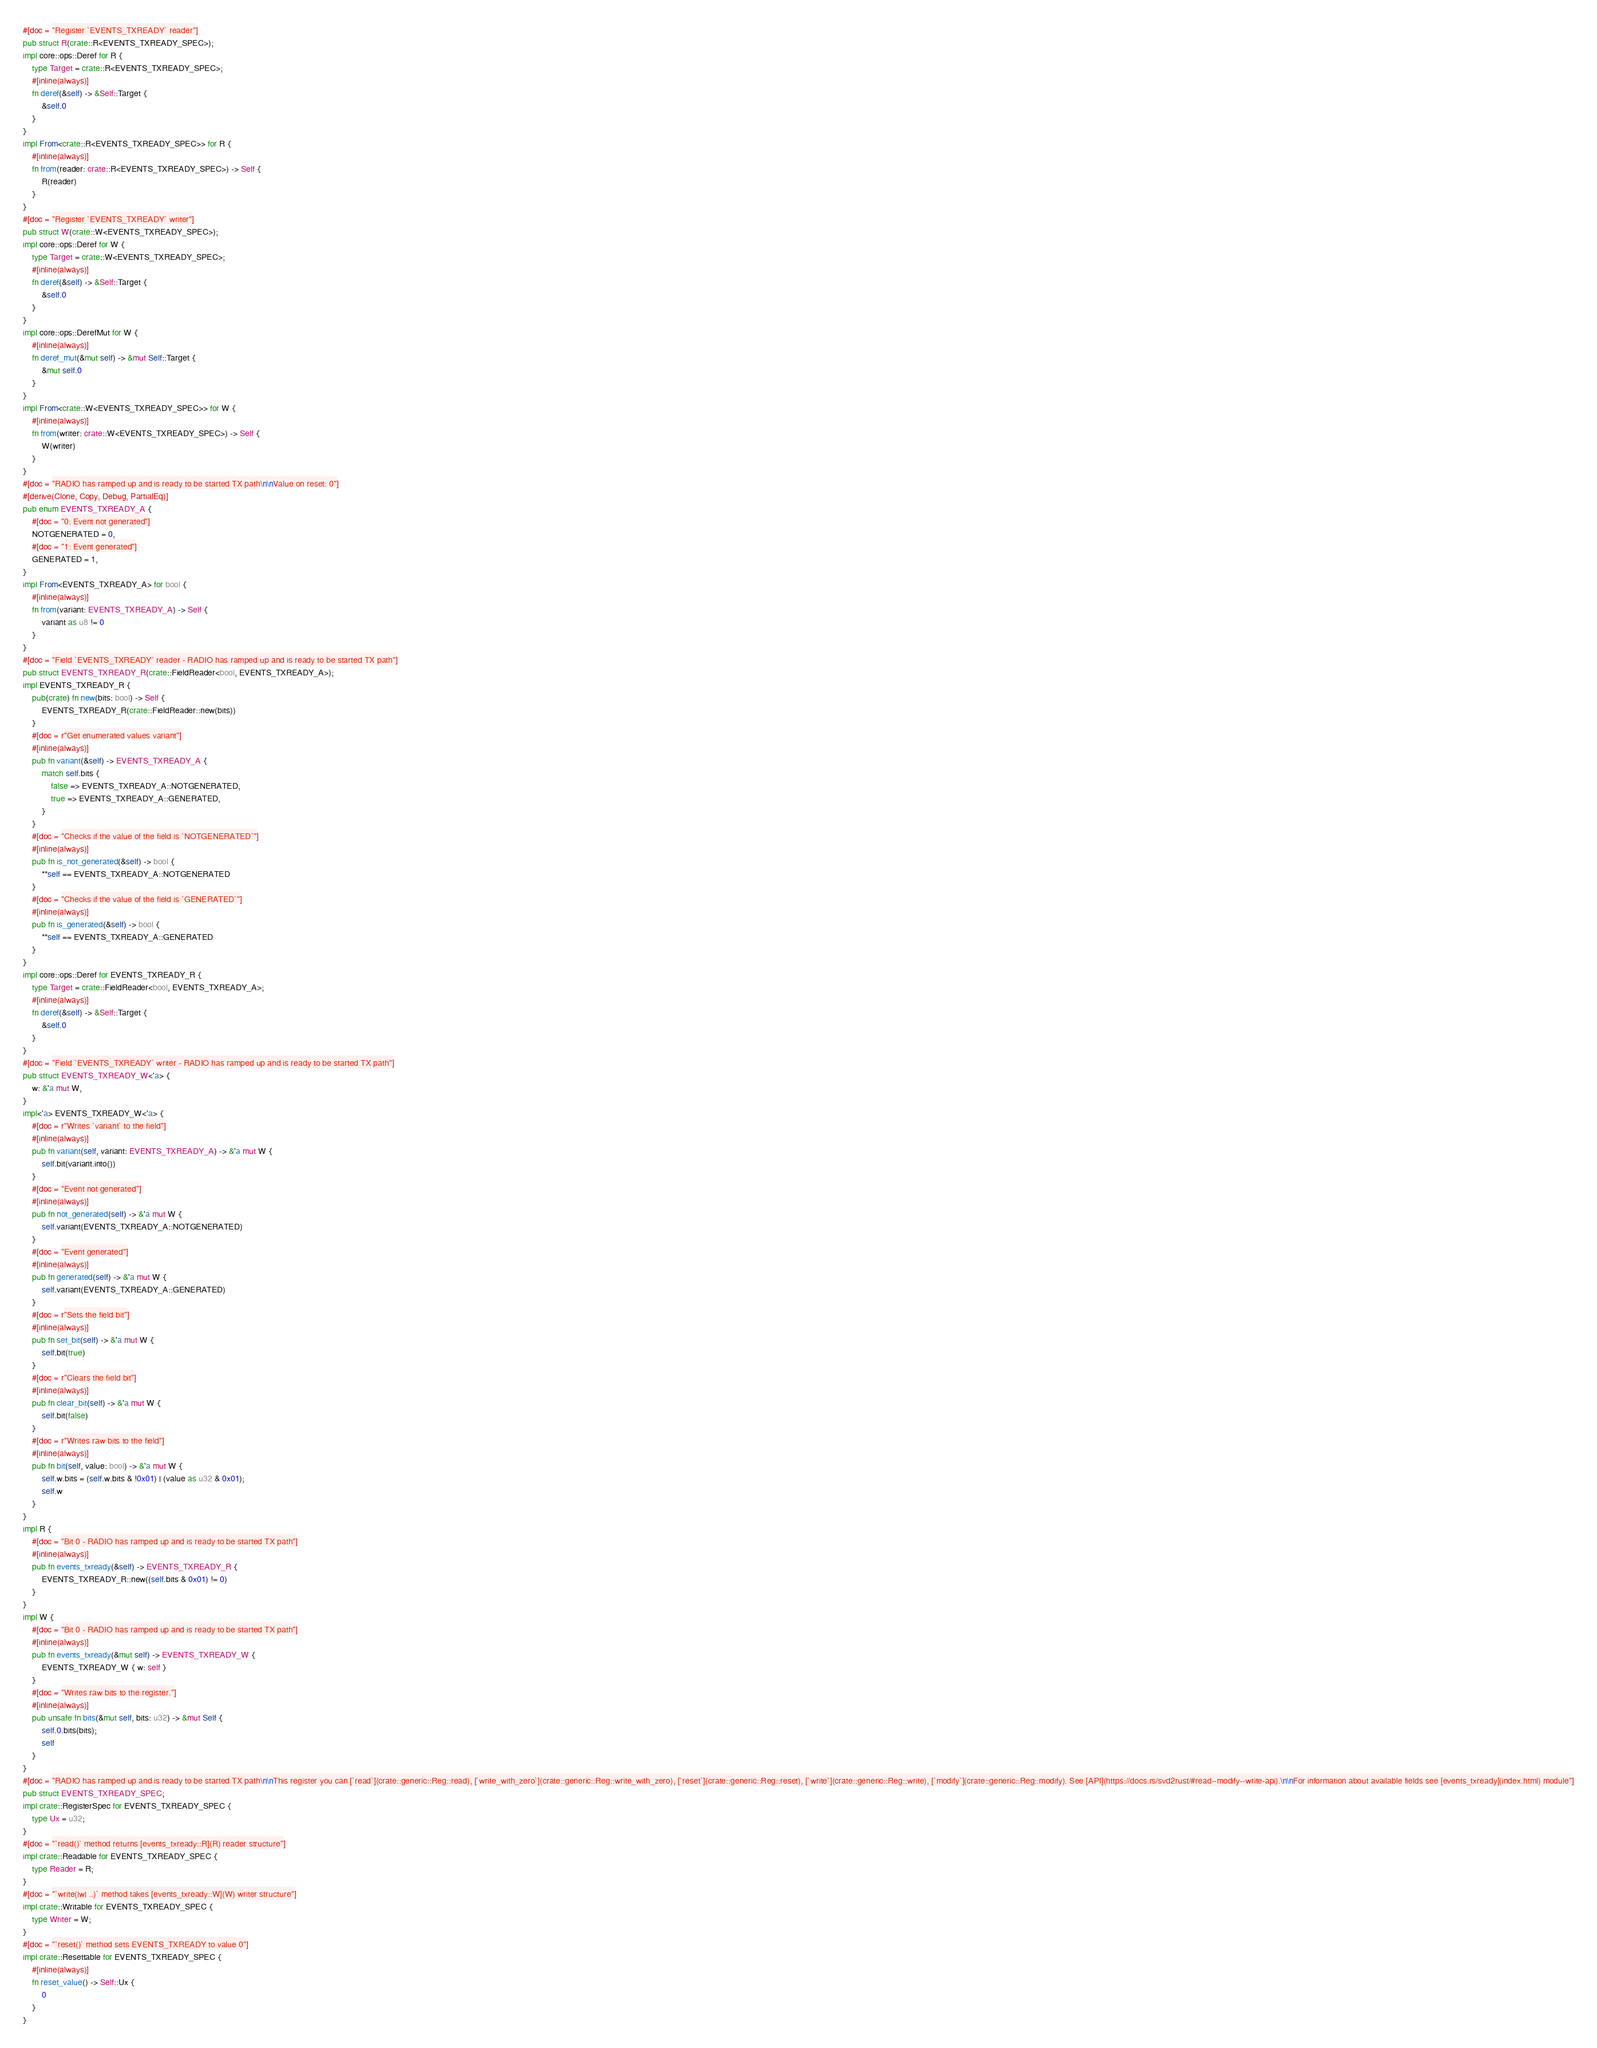<code> <loc_0><loc_0><loc_500><loc_500><_Rust_>#[doc = "Register `EVENTS_TXREADY` reader"]
pub struct R(crate::R<EVENTS_TXREADY_SPEC>);
impl core::ops::Deref for R {
    type Target = crate::R<EVENTS_TXREADY_SPEC>;
    #[inline(always)]
    fn deref(&self) -> &Self::Target {
        &self.0
    }
}
impl From<crate::R<EVENTS_TXREADY_SPEC>> for R {
    #[inline(always)]
    fn from(reader: crate::R<EVENTS_TXREADY_SPEC>) -> Self {
        R(reader)
    }
}
#[doc = "Register `EVENTS_TXREADY` writer"]
pub struct W(crate::W<EVENTS_TXREADY_SPEC>);
impl core::ops::Deref for W {
    type Target = crate::W<EVENTS_TXREADY_SPEC>;
    #[inline(always)]
    fn deref(&self) -> &Self::Target {
        &self.0
    }
}
impl core::ops::DerefMut for W {
    #[inline(always)]
    fn deref_mut(&mut self) -> &mut Self::Target {
        &mut self.0
    }
}
impl From<crate::W<EVENTS_TXREADY_SPEC>> for W {
    #[inline(always)]
    fn from(writer: crate::W<EVENTS_TXREADY_SPEC>) -> Self {
        W(writer)
    }
}
#[doc = "RADIO has ramped up and is ready to be started TX path\n\nValue on reset: 0"]
#[derive(Clone, Copy, Debug, PartialEq)]
pub enum EVENTS_TXREADY_A {
    #[doc = "0: Event not generated"]
    NOTGENERATED = 0,
    #[doc = "1: Event generated"]
    GENERATED = 1,
}
impl From<EVENTS_TXREADY_A> for bool {
    #[inline(always)]
    fn from(variant: EVENTS_TXREADY_A) -> Self {
        variant as u8 != 0
    }
}
#[doc = "Field `EVENTS_TXREADY` reader - RADIO has ramped up and is ready to be started TX path"]
pub struct EVENTS_TXREADY_R(crate::FieldReader<bool, EVENTS_TXREADY_A>);
impl EVENTS_TXREADY_R {
    pub(crate) fn new(bits: bool) -> Self {
        EVENTS_TXREADY_R(crate::FieldReader::new(bits))
    }
    #[doc = r"Get enumerated values variant"]
    #[inline(always)]
    pub fn variant(&self) -> EVENTS_TXREADY_A {
        match self.bits {
            false => EVENTS_TXREADY_A::NOTGENERATED,
            true => EVENTS_TXREADY_A::GENERATED,
        }
    }
    #[doc = "Checks if the value of the field is `NOTGENERATED`"]
    #[inline(always)]
    pub fn is_not_generated(&self) -> bool {
        **self == EVENTS_TXREADY_A::NOTGENERATED
    }
    #[doc = "Checks if the value of the field is `GENERATED`"]
    #[inline(always)]
    pub fn is_generated(&self) -> bool {
        **self == EVENTS_TXREADY_A::GENERATED
    }
}
impl core::ops::Deref for EVENTS_TXREADY_R {
    type Target = crate::FieldReader<bool, EVENTS_TXREADY_A>;
    #[inline(always)]
    fn deref(&self) -> &Self::Target {
        &self.0
    }
}
#[doc = "Field `EVENTS_TXREADY` writer - RADIO has ramped up and is ready to be started TX path"]
pub struct EVENTS_TXREADY_W<'a> {
    w: &'a mut W,
}
impl<'a> EVENTS_TXREADY_W<'a> {
    #[doc = r"Writes `variant` to the field"]
    #[inline(always)]
    pub fn variant(self, variant: EVENTS_TXREADY_A) -> &'a mut W {
        self.bit(variant.into())
    }
    #[doc = "Event not generated"]
    #[inline(always)]
    pub fn not_generated(self) -> &'a mut W {
        self.variant(EVENTS_TXREADY_A::NOTGENERATED)
    }
    #[doc = "Event generated"]
    #[inline(always)]
    pub fn generated(self) -> &'a mut W {
        self.variant(EVENTS_TXREADY_A::GENERATED)
    }
    #[doc = r"Sets the field bit"]
    #[inline(always)]
    pub fn set_bit(self) -> &'a mut W {
        self.bit(true)
    }
    #[doc = r"Clears the field bit"]
    #[inline(always)]
    pub fn clear_bit(self) -> &'a mut W {
        self.bit(false)
    }
    #[doc = r"Writes raw bits to the field"]
    #[inline(always)]
    pub fn bit(self, value: bool) -> &'a mut W {
        self.w.bits = (self.w.bits & !0x01) | (value as u32 & 0x01);
        self.w
    }
}
impl R {
    #[doc = "Bit 0 - RADIO has ramped up and is ready to be started TX path"]
    #[inline(always)]
    pub fn events_txready(&self) -> EVENTS_TXREADY_R {
        EVENTS_TXREADY_R::new((self.bits & 0x01) != 0)
    }
}
impl W {
    #[doc = "Bit 0 - RADIO has ramped up and is ready to be started TX path"]
    #[inline(always)]
    pub fn events_txready(&mut self) -> EVENTS_TXREADY_W {
        EVENTS_TXREADY_W { w: self }
    }
    #[doc = "Writes raw bits to the register."]
    #[inline(always)]
    pub unsafe fn bits(&mut self, bits: u32) -> &mut Self {
        self.0.bits(bits);
        self
    }
}
#[doc = "RADIO has ramped up and is ready to be started TX path\n\nThis register you can [`read`](crate::generic::Reg::read), [`write_with_zero`](crate::generic::Reg::write_with_zero), [`reset`](crate::generic::Reg::reset), [`write`](crate::generic::Reg::write), [`modify`](crate::generic::Reg::modify). See [API](https://docs.rs/svd2rust/#read--modify--write-api).\n\nFor information about available fields see [events_txready](index.html) module"]
pub struct EVENTS_TXREADY_SPEC;
impl crate::RegisterSpec for EVENTS_TXREADY_SPEC {
    type Ux = u32;
}
#[doc = "`read()` method returns [events_txready::R](R) reader structure"]
impl crate::Readable for EVENTS_TXREADY_SPEC {
    type Reader = R;
}
#[doc = "`write(|w| ..)` method takes [events_txready::W](W) writer structure"]
impl crate::Writable for EVENTS_TXREADY_SPEC {
    type Writer = W;
}
#[doc = "`reset()` method sets EVENTS_TXREADY to value 0"]
impl crate::Resettable for EVENTS_TXREADY_SPEC {
    #[inline(always)]
    fn reset_value() -> Self::Ux {
        0
    }
}
</code> 